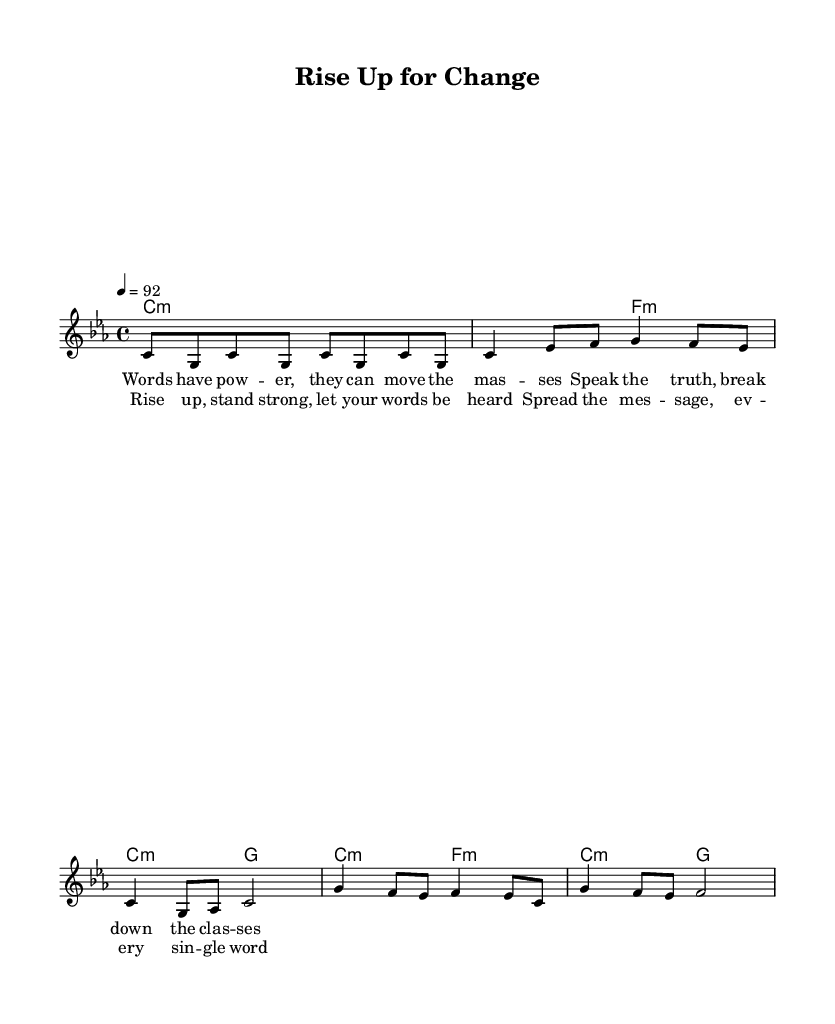What is the key signature of this music? The key signature indicates that the piece is in C minor, which has three flats: B flat, E flat, and A flat. The "c" in "c minor" signifies the tonic of the scale used in the piece.
Answer: C minor What is the time signature of this music? The time signature displayed at the beginning of the piece is 4/4, which means there are four beats in each measure and the quarter note gets one beat. This is a common time signature used for many genres, including reggae.
Answer: 4/4 What is the tempo marking for this piece? The tempo marking indicates that the piece should be played at 92 beats per minute. This specific marking gives performers an idea of the speed at which they should play the piece, which is moderate in reggae music.
Answer: 92 How many measures are in the chorus section? The chorus section consists of two measures based on the melody notes and the lyrics provided, indicating how the music transitions back into the refrain. This structure is essential and commonly found in reggae anthems.
Answer: 2 What do the lyrics in the verse suggest about the social themes of the song? The lyrics mention "Words have power" and "Speak the truth," indicating a strong message about the importance of communication and social justice. This aligns with reggae's historical connection to activism and promoting social change through music.
Answer: Social justice What harmonic structure is used throughout the piece? The harmonic structure is built around minor chords, specifically C minor and its relative progressions. These chords support the emotional intensity typical of reggae music, often reflecting themes of struggle and resilience.
Answer: Minor chords What is the overall theme of the lyrics in this song? The lyrics promote empowerment and resilience, encouraging listeners to "Rise up" and stand strong for change. This encapsulation reflects the essence of reggae music as a vehicle for social change and self-empowerment.
Answer: Empowerment 